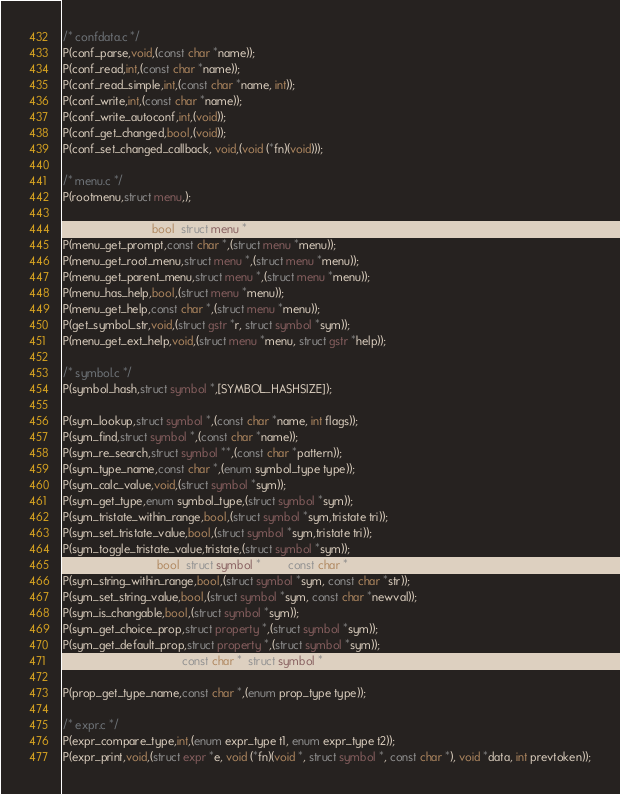<code> <loc_0><loc_0><loc_500><loc_500><_C_>
/* confdata.c */
P(conf_parse,void,(const char *name));
P(conf_read,int,(const char *name));
P(conf_read_simple,int,(const char *name, int));
P(conf_write,int,(const char *name));
P(conf_write_autoconf,int,(void));
P(conf_get_changed,bool,(void));
P(conf_set_changed_callback, void,(void (*fn)(void)));

/* menu.c */
P(rootmenu,struct menu,);

P(menu_is_visible,bool,(struct menu *menu));
P(menu_get_prompt,const char *,(struct menu *menu));
P(menu_get_root_menu,struct menu *,(struct menu *menu));
P(menu_get_parent_menu,struct menu *,(struct menu *menu));
P(menu_has_help,bool,(struct menu *menu));
P(menu_get_help,const char *,(struct menu *menu));
P(get_symbol_str,void,(struct gstr *r, struct symbol *sym));
P(menu_get_ext_help,void,(struct menu *menu, struct gstr *help));

/* symbol.c */
P(symbol_hash,struct symbol *,[SYMBOL_HASHSIZE]);

P(sym_lookup,struct symbol *,(const char *name, int flags));
P(sym_find,struct symbol *,(const char *name));
P(sym_re_search,struct symbol **,(const char *pattern));
P(sym_type_name,const char *,(enum symbol_type type));
P(sym_calc_value,void,(struct symbol *sym));
P(sym_get_type,enum symbol_type,(struct symbol *sym));
P(sym_tristate_within_range,bool,(struct symbol *sym,tristate tri));
P(sym_set_tristate_value,bool,(struct symbol *sym,tristate tri));
P(sym_toggle_tristate_value,tristate,(struct symbol *sym));
P(sym_string_valid,bool,(struct symbol *sym, const char *newval));
P(sym_string_within_range,bool,(struct symbol *sym, const char *str));
P(sym_set_string_value,bool,(struct symbol *sym, const char *newval));
P(sym_is_changable,bool,(struct symbol *sym));
P(sym_get_choice_prop,struct property *,(struct symbol *sym));
P(sym_get_default_prop,struct property *,(struct symbol *sym));
P(sym_get_string_value,const char *,(struct symbol *sym));

P(prop_get_type_name,const char *,(enum prop_type type));

/* expr.c */
P(expr_compare_type,int,(enum expr_type t1, enum expr_type t2));
P(expr_print,void,(struct expr *e, void (*fn)(void *, struct symbol *, const char *), void *data, int prevtoken));
</code> 